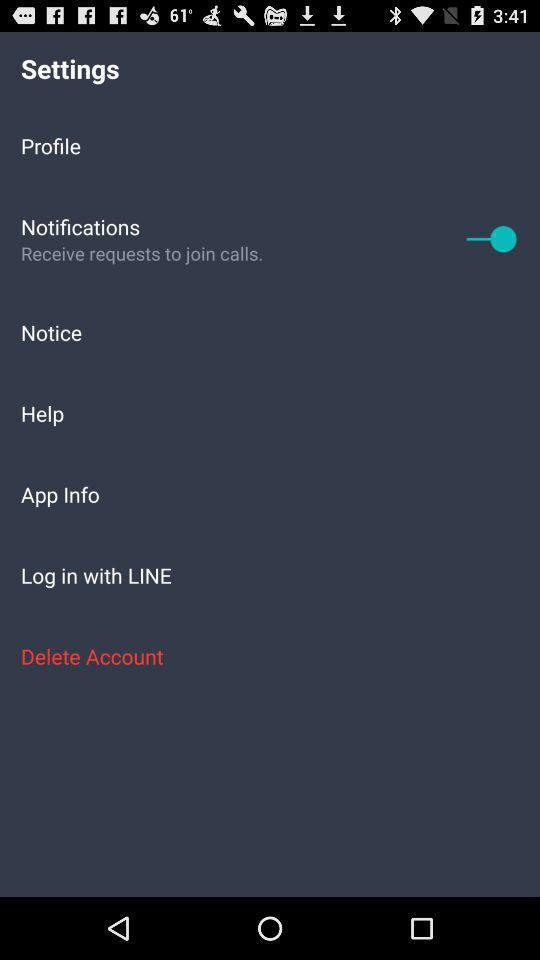What is the status of the "Notifications"? The status of the "Notifications" is "on". 